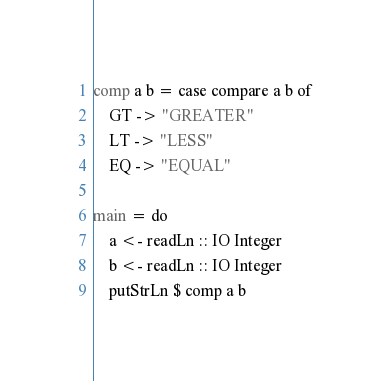Convert code to text. <code><loc_0><loc_0><loc_500><loc_500><_Haskell_>comp a b = case compare a b of
    GT -> "GREATER"
    LT -> "LESS"
    EQ -> "EQUAL"

main = do
    a <- readLn :: IO Integer
    b <- readLn :: IO Integer
    putStrLn $ comp a b
</code> 